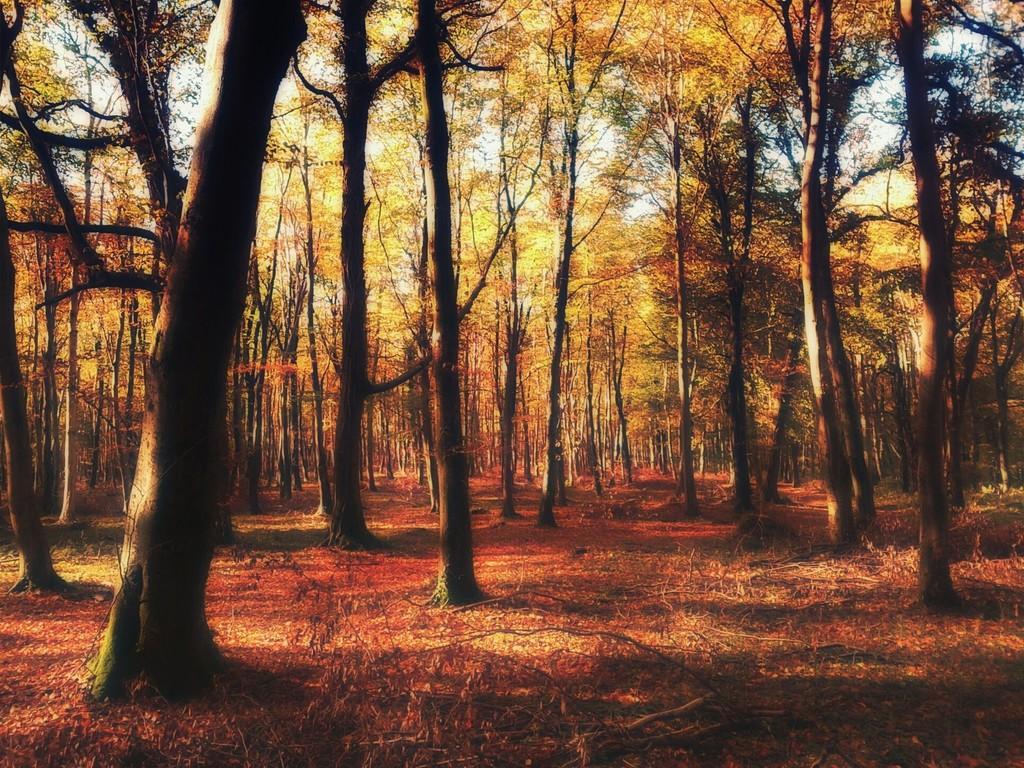Please provide a concise description of this image. This is an edited picture. At the bottom of the picture there are dry leaves, grass and stems. In the center of the picture there are trees. 